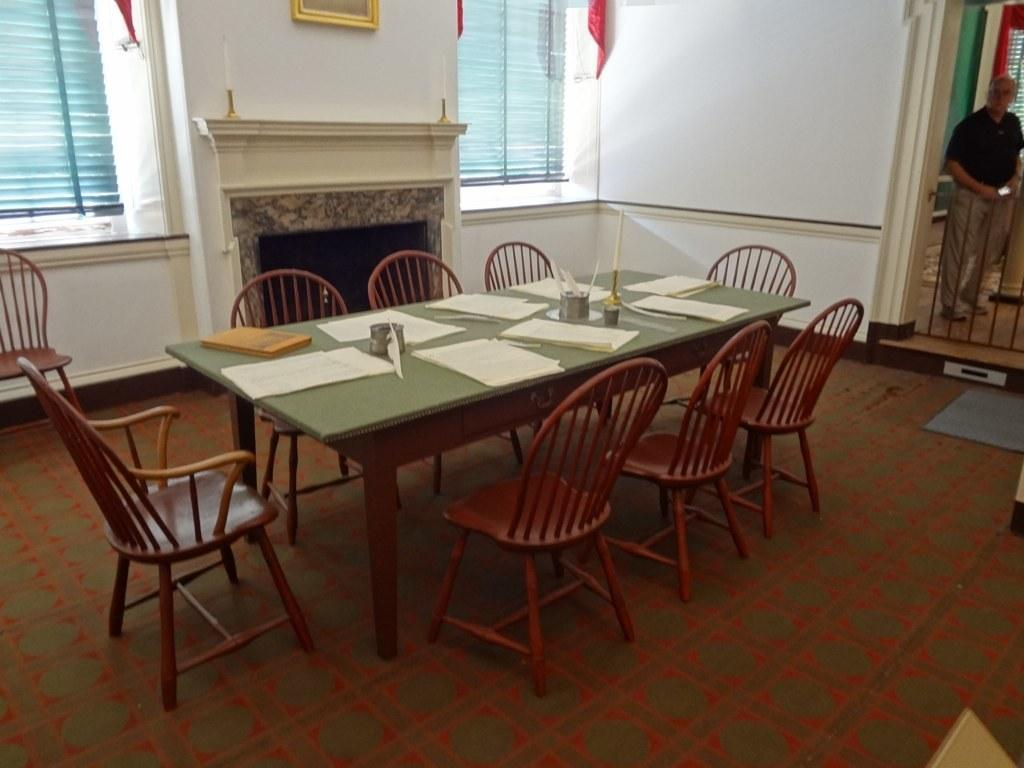What type of furniture is the main subject in the image? There is a big table in the image. What is located around the table? There are chairs around the table. Can you describe the person in the image? A man is standing in the image. What is placed on the table? There is a candle and papers on the table. What type of scent can be detected from the candle in the image? There is no information about the scent of the candle in the image, so it cannot be determined. 